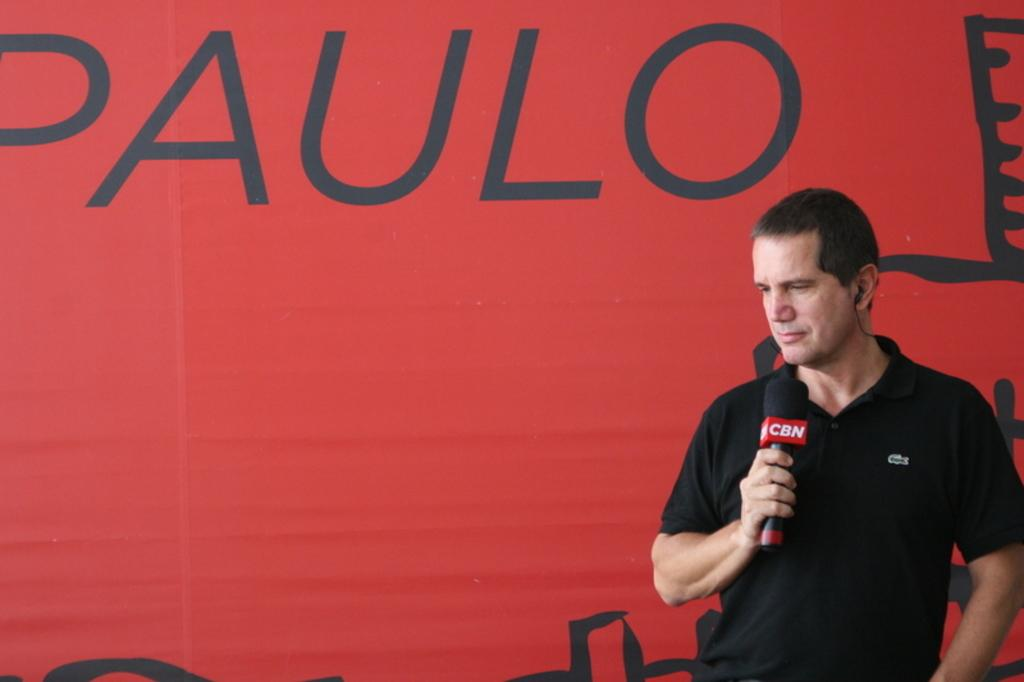What is the main subject of the image? There is a person in the image. What is the person wearing? The person is wearing a black dress. What is the person holding in the image? The person is holding a microphone. What color is the background in the image? The background in the image is red. What can be seen on the red background? There is text or writing on the red background. Can you hear the person whistling in the image? There is no whistling present in the image; the person is holding a microphone. How many pages of the book can be seen in the image? There is no book present in the image, only a person holding a microphone and text on a red background. 